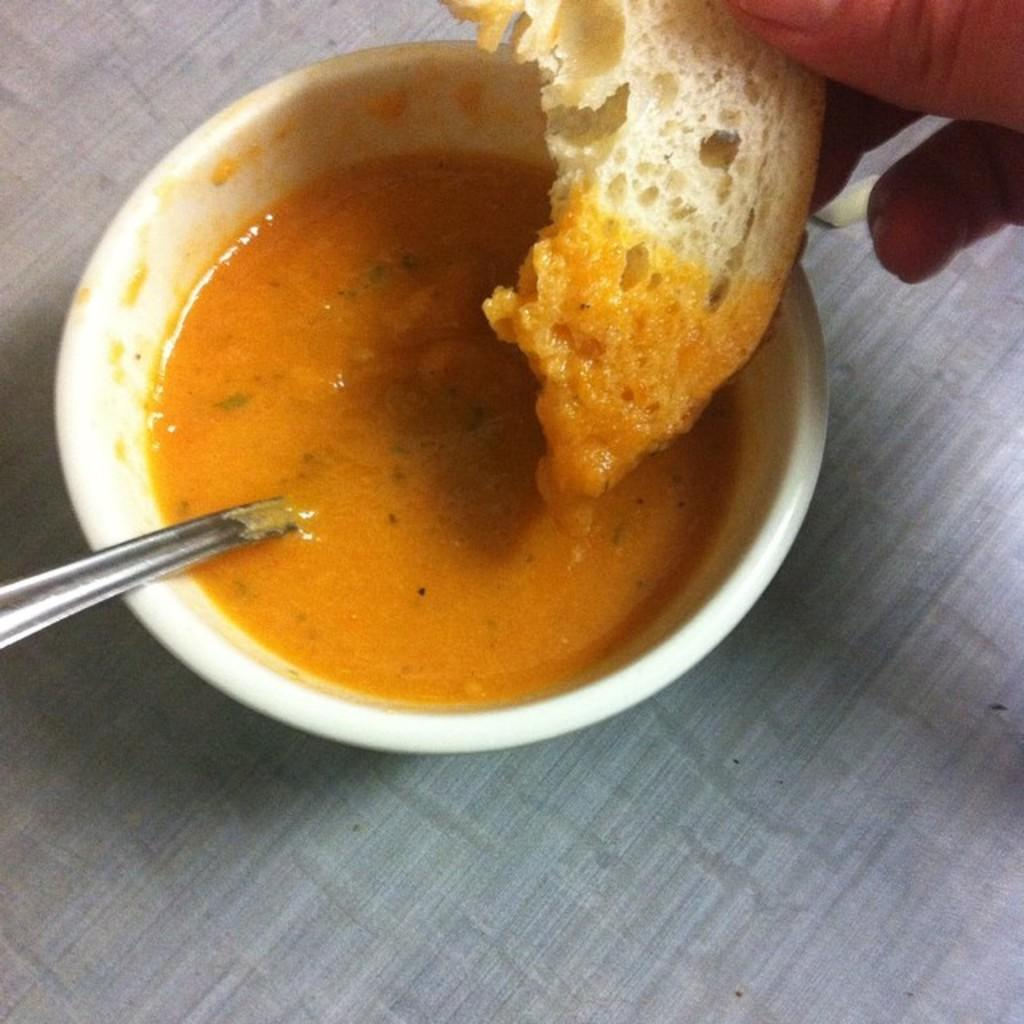What type of food is present in the image? The image contains food. What utensil is used with the food in the image? There is a spoon in the bowl. Can you describe any body parts visible in the image? A hand is visible on the right side of the image. What type of bun is being held by the men in the image? There are no men present in the image, and therefore no bun being held. 